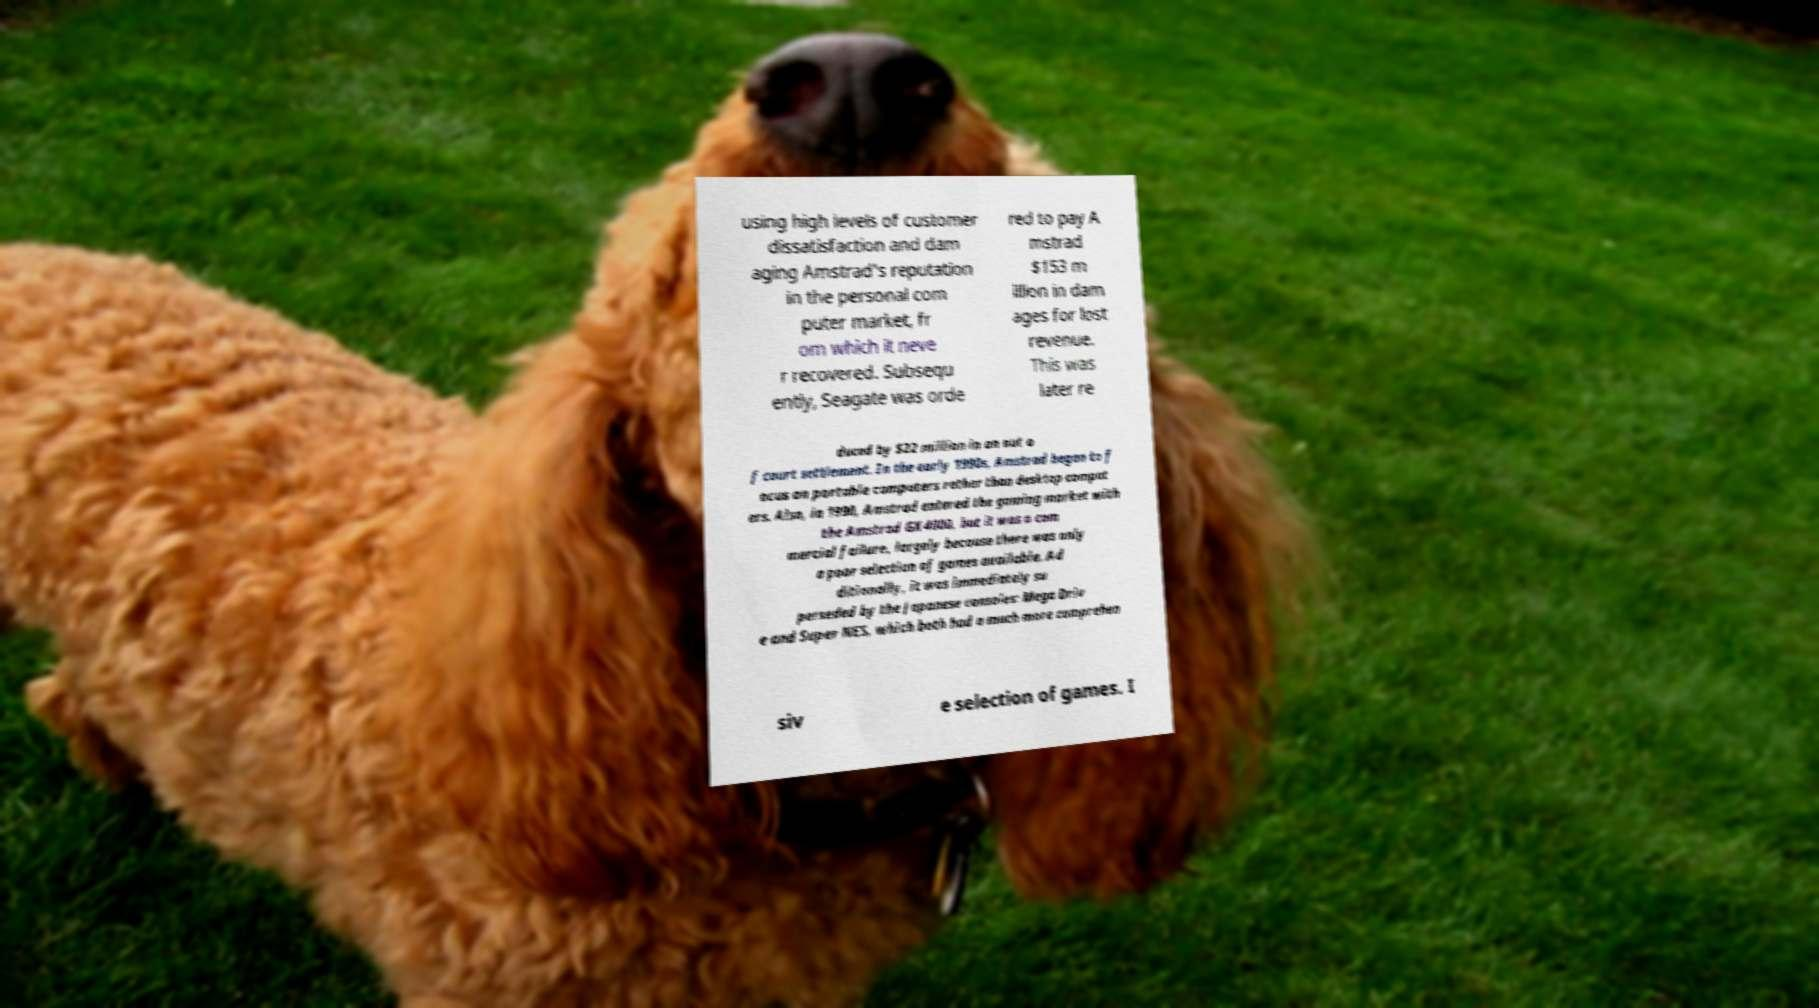Please read and relay the text visible in this image. What does it say? using high levels of customer dissatisfaction and dam aging Amstrad's reputation in the personal com puter market, fr om which it neve r recovered. Subsequ ently, Seagate was orde red to pay A mstrad $153 m illion in dam ages for lost revenue. This was later re duced by $22 million in an out o f court settlement. In the early 1990s, Amstrad began to f ocus on portable computers rather than desktop comput ers. Also, in 1990, Amstrad entered the gaming market with the Amstrad GX4000, but it was a com mercial failure, largely because there was only a poor selection of games available. Ad ditionally, it was immediately su perseded by the Japanese consoles: Mega Driv e and Super NES, which both had a much more comprehen siv e selection of games. I 